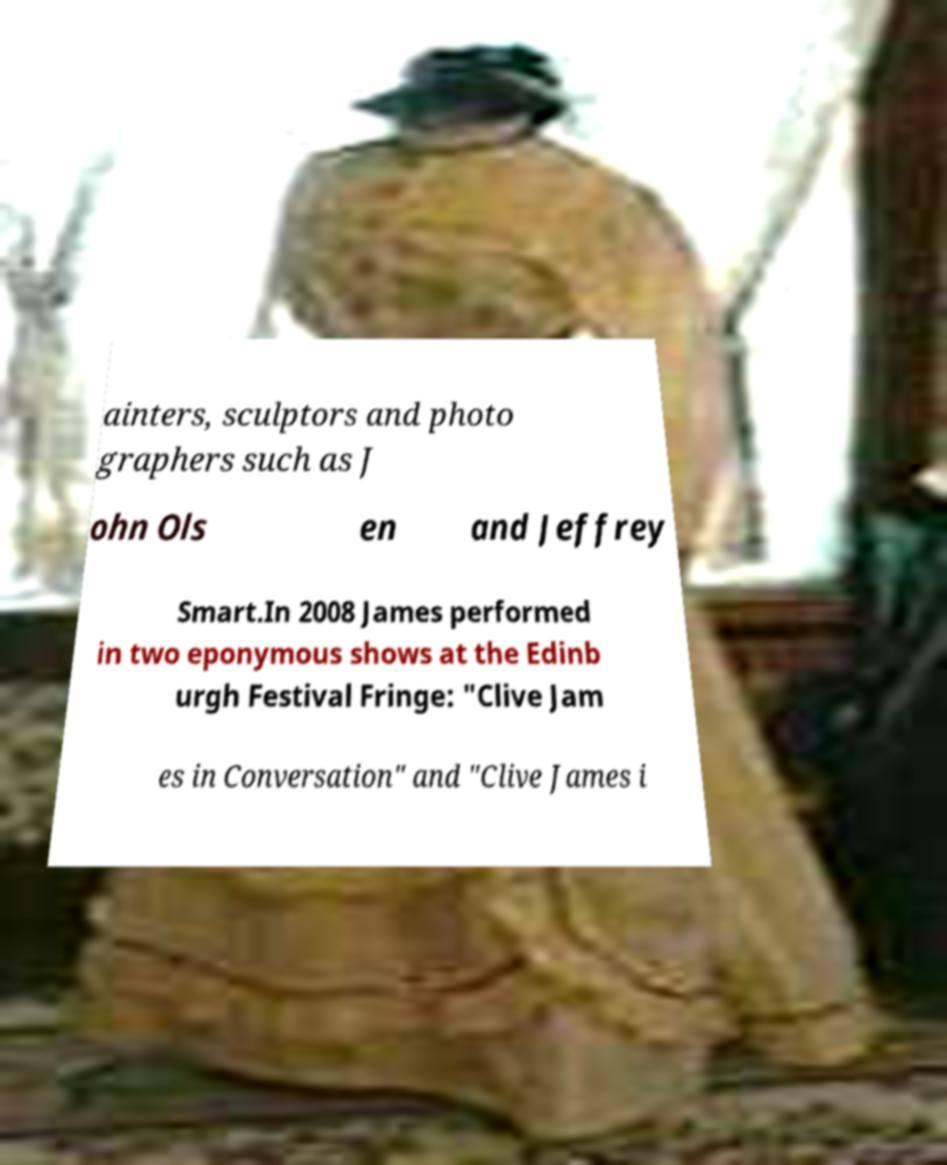Can you accurately transcribe the text from the provided image for me? ainters, sculptors and photo graphers such as J ohn Ols en and Jeffrey Smart.In 2008 James performed in two eponymous shows at the Edinb urgh Festival Fringe: "Clive Jam es in Conversation" and "Clive James i 